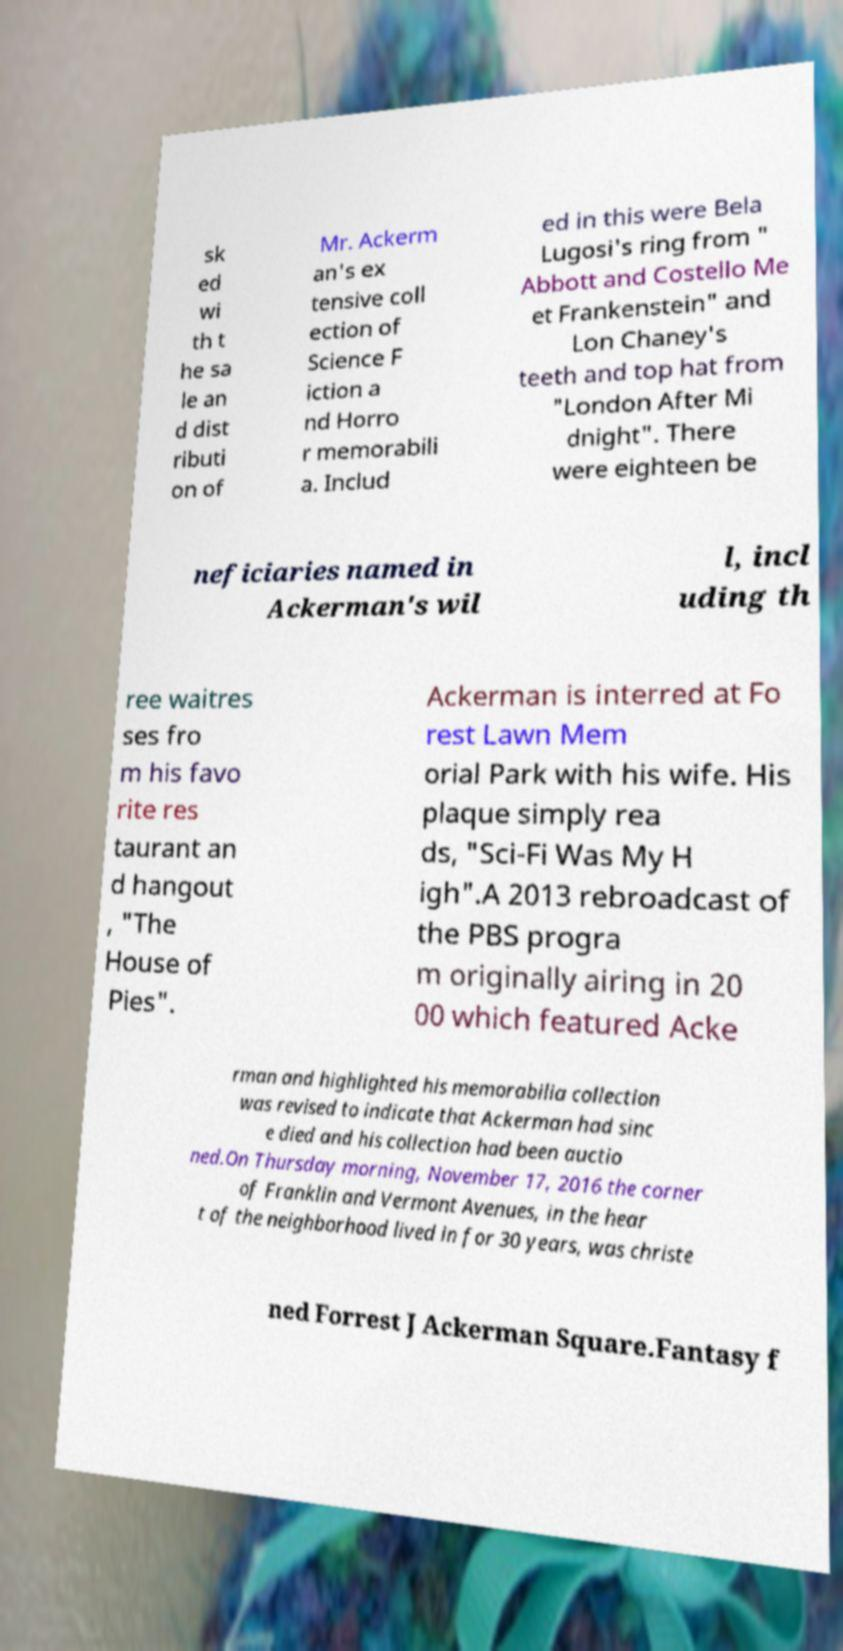Could you assist in decoding the text presented in this image and type it out clearly? sk ed wi th t he sa le an d dist ributi on of Mr. Ackerm an's ex tensive coll ection of Science F iction a nd Horro r memorabili a. Includ ed in this were Bela Lugosi's ring from " Abbott and Costello Me et Frankenstein" and Lon Chaney's teeth and top hat from "London After Mi dnight". There were eighteen be neficiaries named in Ackerman's wil l, incl uding th ree waitres ses fro m his favo rite res taurant an d hangout , "The House of Pies". Ackerman is interred at Fo rest Lawn Mem orial Park with his wife. His plaque simply rea ds, "Sci-Fi Was My H igh".A 2013 rebroadcast of the PBS progra m originally airing in 20 00 which featured Acke rman and highlighted his memorabilia collection was revised to indicate that Ackerman had sinc e died and his collection had been auctio ned.On Thursday morning, November 17, 2016 the corner of Franklin and Vermont Avenues, in the hear t of the neighborhood lived in for 30 years, was christe ned Forrest J Ackerman Square.Fantasy f 